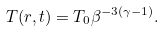Convert formula to latex. <formula><loc_0><loc_0><loc_500><loc_500>T ( r , t ) = T _ { 0 } \beta ^ { - 3 ( \gamma - 1 ) } .</formula> 